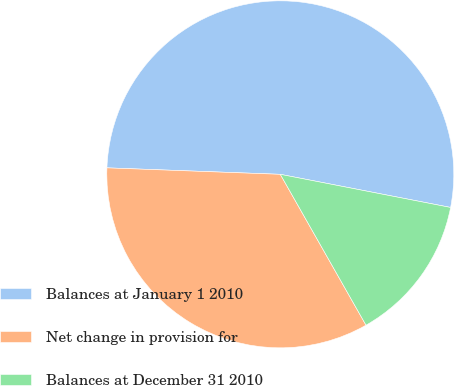Convert chart. <chart><loc_0><loc_0><loc_500><loc_500><pie_chart><fcel>Balances at January 1 2010<fcel>Net change in provision for<fcel>Balances at December 31 2010<nl><fcel>52.47%<fcel>33.82%<fcel>13.72%<nl></chart> 